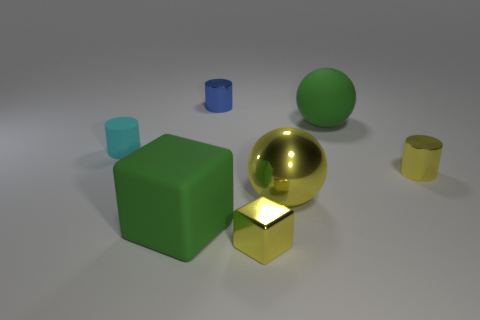What number of things are behind the tiny yellow cylinder and to the right of the tiny rubber thing?
Your answer should be very brief. 2. There is a tiny yellow thing right of the yellow metallic ball; what shape is it?
Offer a very short reply. Cylinder. What number of blue things have the same size as the yellow cube?
Make the answer very short. 1. Do the small shiny object right of the matte sphere and the matte cylinder have the same color?
Give a very brief answer. No. What is the cylinder that is in front of the tiny blue metallic cylinder and on the right side of the big green rubber block made of?
Your response must be concise. Metal. Is the number of things greater than the number of tiny yellow shiny objects?
Keep it short and to the point. Yes. What is the color of the thing in front of the big green thing in front of the tiny yellow thing behind the tiny yellow cube?
Your answer should be compact. Yellow. Is the material of the tiny cylinder behind the rubber cylinder the same as the green sphere?
Make the answer very short. No. Is there a tiny metal object that has the same color as the large metal sphere?
Ensure brevity in your answer.  Yes. Are any small matte things visible?
Your response must be concise. Yes. 